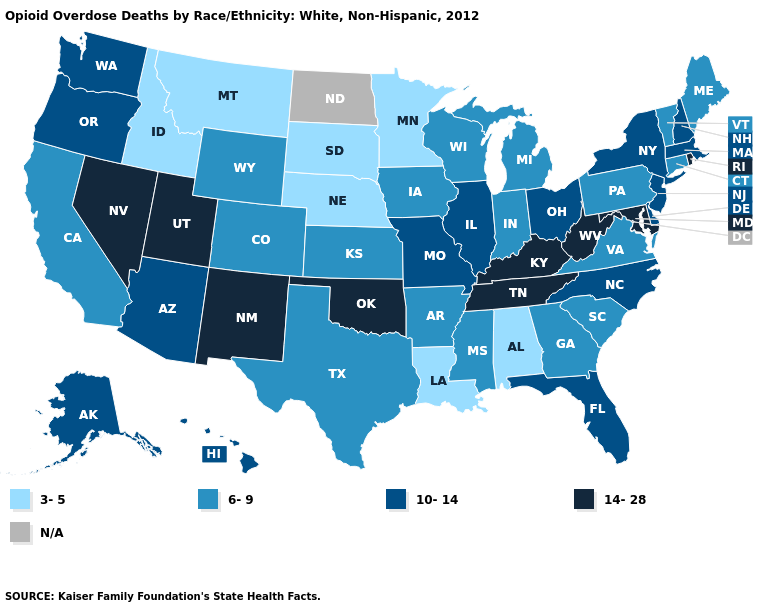What is the highest value in states that border Maine?
Answer briefly. 10-14. Is the legend a continuous bar?
Be succinct. No. What is the lowest value in states that border Indiana?
Give a very brief answer. 6-9. Does the first symbol in the legend represent the smallest category?
Quick response, please. Yes. What is the value of Washington?
Concise answer only. 10-14. What is the value of Montana?
Answer briefly. 3-5. What is the value of California?
Keep it brief. 6-9. What is the highest value in states that border Maine?
Keep it brief. 10-14. What is the lowest value in the USA?
Write a very short answer. 3-5. What is the value of Arkansas?
Write a very short answer. 6-9. What is the value of New Hampshire?
Write a very short answer. 10-14. Is the legend a continuous bar?
Keep it brief. No. Among the states that border Kansas , which have the lowest value?
Be succinct. Nebraska. Which states have the lowest value in the USA?
Write a very short answer. Alabama, Idaho, Louisiana, Minnesota, Montana, Nebraska, South Dakota. 